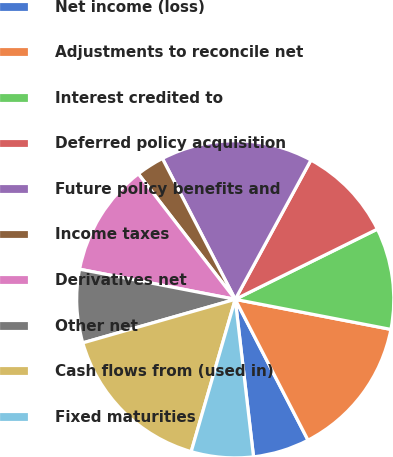<chart> <loc_0><loc_0><loc_500><loc_500><pie_chart><fcel>Net income (loss)<fcel>Adjustments to reconcile net<fcel>Interest credited to<fcel>Deferred policy acquisition<fcel>Future policy benefits and<fcel>Income taxes<fcel>Derivatives net<fcel>Other net<fcel>Cash flows from (used in)<fcel>Fixed maturities<nl><fcel>5.75%<fcel>14.37%<fcel>10.34%<fcel>9.77%<fcel>15.52%<fcel>2.87%<fcel>11.49%<fcel>7.47%<fcel>16.09%<fcel>6.32%<nl></chart> 